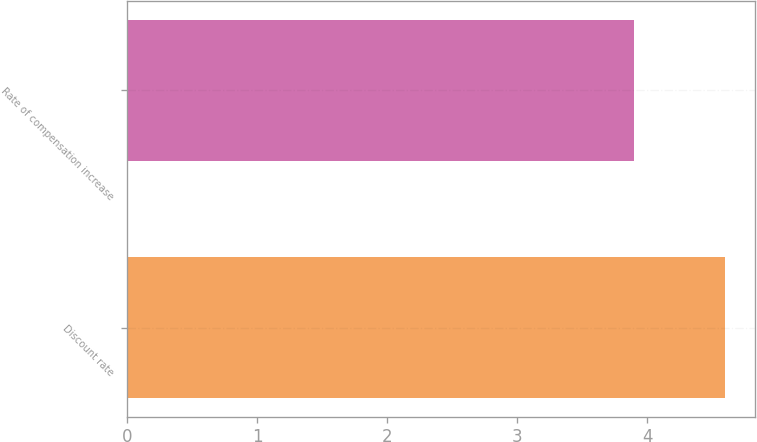<chart> <loc_0><loc_0><loc_500><loc_500><bar_chart><fcel>Discount rate<fcel>Rate of compensation increase<nl><fcel>4.6<fcel>3.9<nl></chart> 